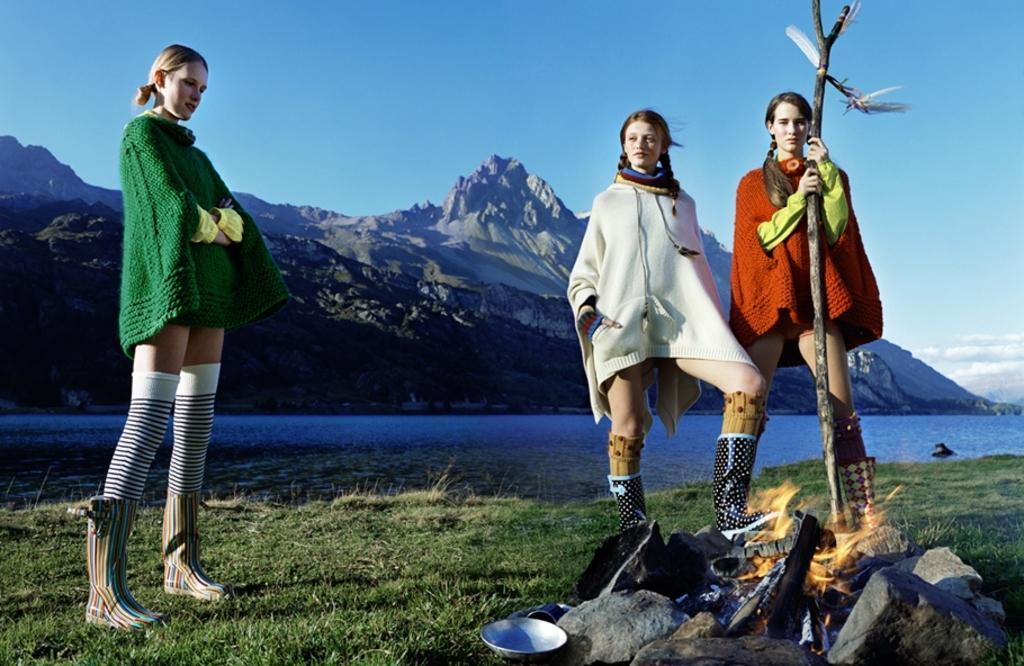How would you summarize this image in a sentence or two? This image is taken outdoors. At the top of the image there is the sky with clouds. In the background there are a few hills. There is a river with water. At the bottom of the image there is a ground with grass on it. There are a few stones on the ground. On the left side of the image a girl is standing on the ground. On the right side of the image two girls are standing on the ground and a girl is holding a stick in her hands. There is a plate on the ground and there is a campfire. 